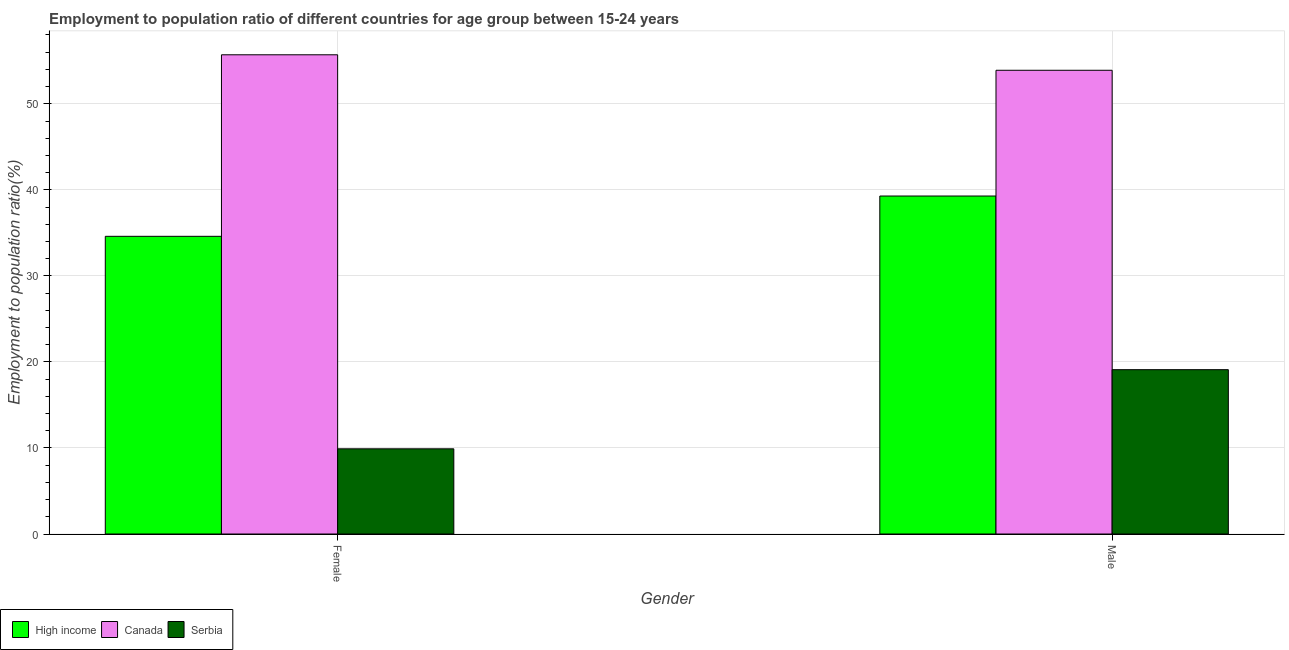How many bars are there on the 1st tick from the left?
Your answer should be very brief. 3. How many bars are there on the 1st tick from the right?
Give a very brief answer. 3. What is the label of the 2nd group of bars from the left?
Keep it short and to the point. Male. What is the employment to population ratio(male) in Serbia?
Your answer should be very brief. 19.1. Across all countries, what is the maximum employment to population ratio(male)?
Offer a very short reply. 53.9. Across all countries, what is the minimum employment to population ratio(female)?
Keep it short and to the point. 9.9. In which country was the employment to population ratio(female) maximum?
Provide a succinct answer. Canada. In which country was the employment to population ratio(male) minimum?
Offer a very short reply. Serbia. What is the total employment to population ratio(male) in the graph?
Give a very brief answer. 112.28. What is the difference between the employment to population ratio(male) in Serbia and that in High income?
Provide a short and direct response. -20.18. What is the difference between the employment to population ratio(female) in Canada and the employment to population ratio(male) in High income?
Provide a succinct answer. 16.42. What is the average employment to population ratio(female) per country?
Your answer should be compact. 33.4. What is the difference between the employment to population ratio(female) and employment to population ratio(male) in Canada?
Offer a very short reply. 1.8. What is the ratio of the employment to population ratio(male) in Serbia to that in Canada?
Give a very brief answer. 0.35. Is the employment to population ratio(male) in Serbia less than that in Canada?
Your answer should be very brief. Yes. In how many countries, is the employment to population ratio(male) greater than the average employment to population ratio(male) taken over all countries?
Offer a terse response. 2. What does the 3rd bar from the left in Female represents?
Give a very brief answer. Serbia. What does the 1st bar from the right in Male represents?
Ensure brevity in your answer.  Serbia. How many bars are there?
Your response must be concise. 6. How many countries are there in the graph?
Give a very brief answer. 3. Are the values on the major ticks of Y-axis written in scientific E-notation?
Your answer should be very brief. No. Does the graph contain any zero values?
Provide a succinct answer. No. Does the graph contain grids?
Ensure brevity in your answer.  Yes. Where does the legend appear in the graph?
Your response must be concise. Bottom left. What is the title of the graph?
Keep it short and to the point. Employment to population ratio of different countries for age group between 15-24 years. What is the label or title of the X-axis?
Your answer should be compact. Gender. What is the label or title of the Y-axis?
Offer a terse response. Employment to population ratio(%). What is the Employment to population ratio(%) of High income in Female?
Your answer should be very brief. 34.6. What is the Employment to population ratio(%) in Canada in Female?
Your answer should be compact. 55.7. What is the Employment to population ratio(%) in Serbia in Female?
Give a very brief answer. 9.9. What is the Employment to population ratio(%) of High income in Male?
Ensure brevity in your answer.  39.28. What is the Employment to population ratio(%) in Canada in Male?
Provide a succinct answer. 53.9. What is the Employment to population ratio(%) in Serbia in Male?
Give a very brief answer. 19.1. Across all Gender, what is the maximum Employment to population ratio(%) in High income?
Your response must be concise. 39.28. Across all Gender, what is the maximum Employment to population ratio(%) in Canada?
Ensure brevity in your answer.  55.7. Across all Gender, what is the maximum Employment to population ratio(%) of Serbia?
Offer a terse response. 19.1. Across all Gender, what is the minimum Employment to population ratio(%) in High income?
Offer a very short reply. 34.6. Across all Gender, what is the minimum Employment to population ratio(%) of Canada?
Offer a very short reply. 53.9. Across all Gender, what is the minimum Employment to population ratio(%) of Serbia?
Keep it short and to the point. 9.9. What is the total Employment to population ratio(%) of High income in the graph?
Your response must be concise. 73.88. What is the total Employment to population ratio(%) in Canada in the graph?
Give a very brief answer. 109.6. What is the total Employment to population ratio(%) of Serbia in the graph?
Ensure brevity in your answer.  29. What is the difference between the Employment to population ratio(%) in High income in Female and that in Male?
Provide a short and direct response. -4.68. What is the difference between the Employment to population ratio(%) of High income in Female and the Employment to population ratio(%) of Canada in Male?
Offer a very short reply. -19.3. What is the difference between the Employment to population ratio(%) of High income in Female and the Employment to population ratio(%) of Serbia in Male?
Provide a succinct answer. 15.5. What is the difference between the Employment to population ratio(%) in Canada in Female and the Employment to population ratio(%) in Serbia in Male?
Your answer should be very brief. 36.6. What is the average Employment to population ratio(%) in High income per Gender?
Your answer should be very brief. 36.94. What is the average Employment to population ratio(%) of Canada per Gender?
Provide a short and direct response. 54.8. What is the average Employment to population ratio(%) in Serbia per Gender?
Keep it short and to the point. 14.5. What is the difference between the Employment to population ratio(%) in High income and Employment to population ratio(%) in Canada in Female?
Your answer should be very brief. -21.1. What is the difference between the Employment to population ratio(%) of High income and Employment to population ratio(%) of Serbia in Female?
Keep it short and to the point. 24.7. What is the difference between the Employment to population ratio(%) in Canada and Employment to population ratio(%) in Serbia in Female?
Ensure brevity in your answer.  45.8. What is the difference between the Employment to population ratio(%) in High income and Employment to population ratio(%) in Canada in Male?
Give a very brief answer. -14.62. What is the difference between the Employment to population ratio(%) in High income and Employment to population ratio(%) in Serbia in Male?
Make the answer very short. 20.18. What is the difference between the Employment to population ratio(%) in Canada and Employment to population ratio(%) in Serbia in Male?
Your answer should be very brief. 34.8. What is the ratio of the Employment to population ratio(%) in High income in Female to that in Male?
Make the answer very short. 0.88. What is the ratio of the Employment to population ratio(%) of Canada in Female to that in Male?
Make the answer very short. 1.03. What is the ratio of the Employment to population ratio(%) in Serbia in Female to that in Male?
Your response must be concise. 0.52. What is the difference between the highest and the second highest Employment to population ratio(%) in High income?
Keep it short and to the point. 4.68. What is the difference between the highest and the second highest Employment to population ratio(%) in Serbia?
Offer a very short reply. 9.2. What is the difference between the highest and the lowest Employment to population ratio(%) in High income?
Make the answer very short. 4.68. What is the difference between the highest and the lowest Employment to population ratio(%) of Canada?
Your answer should be compact. 1.8. 